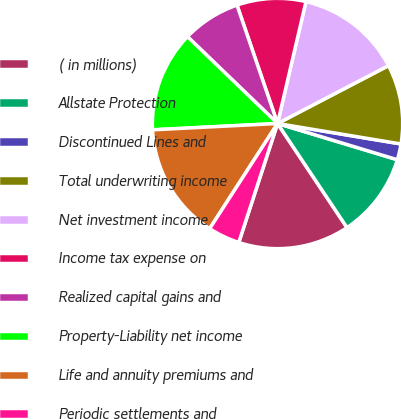<chart> <loc_0><loc_0><loc_500><loc_500><pie_chart><fcel>( in millions)<fcel>Allstate Protection<fcel>Discontinued Lines and<fcel>Total underwriting income<fcel>Net investment income<fcel>Income tax expense on<fcel>Realized capital gains and<fcel>Property-Liability net income<fcel>Life and annuity premiums and<fcel>Periodic settlements and<nl><fcel>14.38%<fcel>10.96%<fcel>2.06%<fcel>10.27%<fcel>13.7%<fcel>8.9%<fcel>7.54%<fcel>13.01%<fcel>15.07%<fcel>4.11%<nl></chart> 